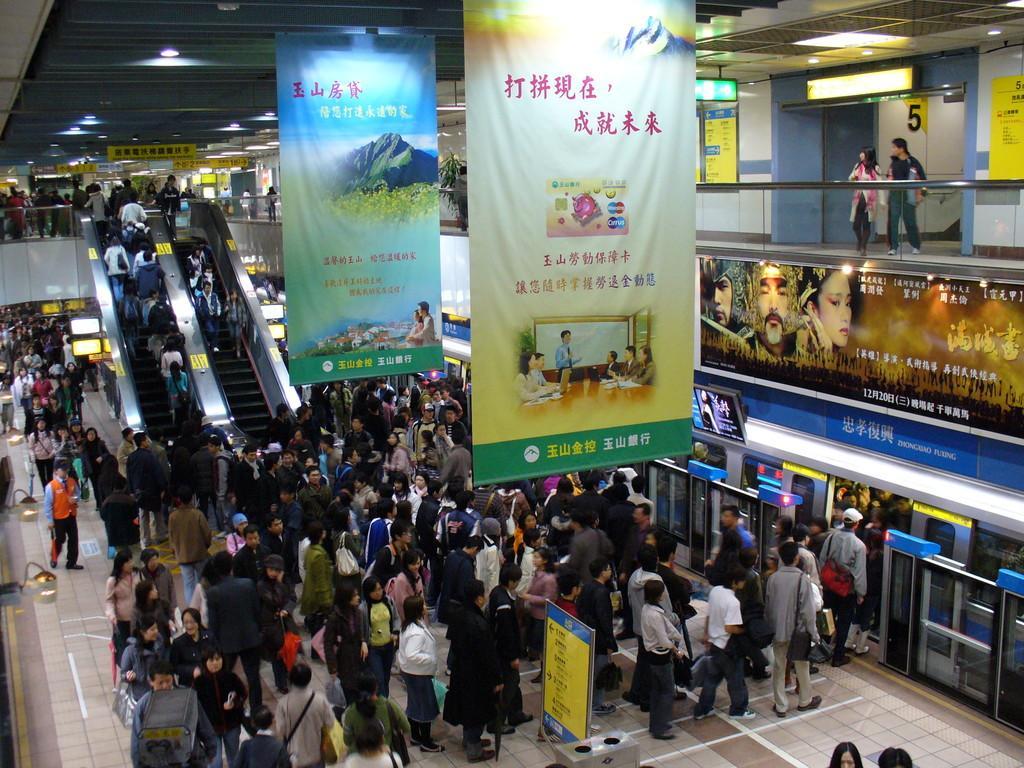How would you summarize this image in a sentence or two? In this image we can see so many people on the platform and on the escalator. At the top of the image, we can see a roof and banners. On the right side of the image, we can see a train, board and railing. Behind the railing, we can see two people are standing. We can see posts attached to the wall. We can see a board at the bottom of the image. 